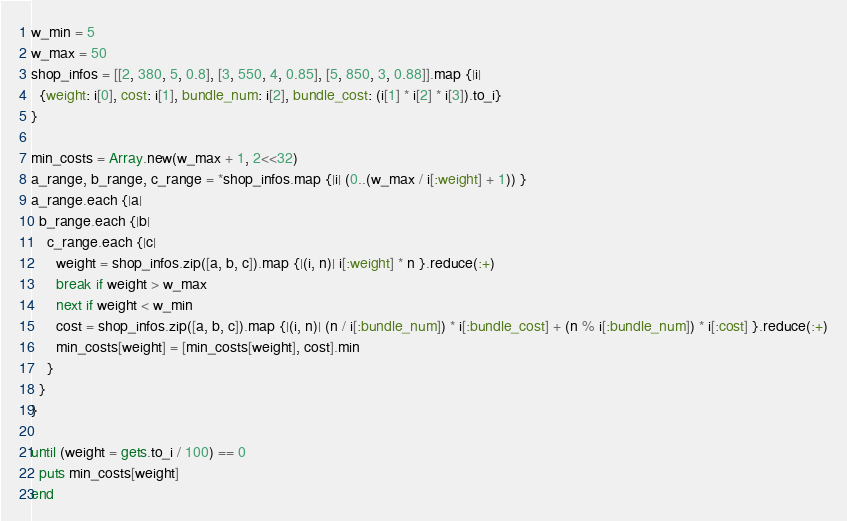<code> <loc_0><loc_0><loc_500><loc_500><_Ruby_>w_min = 5
w_max = 50
shop_infos = [[2, 380, 5, 0.8], [3, 550, 4, 0.85], [5, 850, 3, 0.88]].map {|i|
  {weight: i[0], cost: i[1], bundle_num: i[2], bundle_cost: (i[1] * i[2] * i[3]).to_i}
}

min_costs = Array.new(w_max + 1, 2<<32)
a_range, b_range, c_range = *shop_infos.map {|i| (0..(w_max / i[:weight] + 1)) }
a_range.each {|a|
  b_range.each {|b|
    c_range.each {|c|
      weight = shop_infos.zip([a, b, c]).map {|(i, n)| i[:weight] * n }.reduce(:+)
      break if weight > w_max
      next if weight < w_min
      cost = shop_infos.zip([a, b, c]).map {|(i, n)| (n / i[:bundle_num]) * i[:bundle_cost] + (n % i[:bundle_num]) * i[:cost] }.reduce(:+)
      min_costs[weight] = [min_costs[weight], cost].min
    }
  }
}

until (weight = gets.to_i / 100) == 0
  puts min_costs[weight]
end</code> 